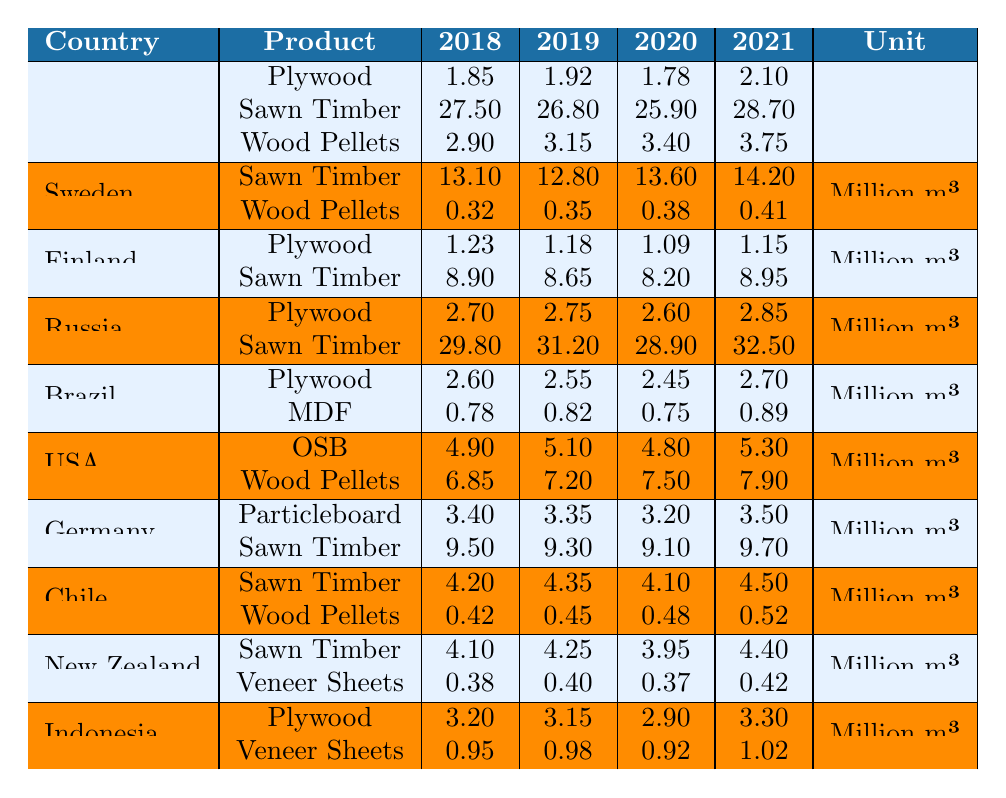What was the export volume of Sawn Timber from Canada in 2021? The table shows that exports of Sawn Timber from Canada in 2021 were 28.70 million m³.
Answer: 28.70 million m³ Which country exported the most Sawn Timber in 2020? By looking at the values for Sawn Timber in 2020, Russia exported 28.90 million m³, which is higher than any other country listed for that year.
Answer: Russia What was the total export volume of Wood Pellets from Sweden over the years 2018 to 2021? The exports of Wood Pellets from Sweden for each year are: 0.32 + 0.35 + 0.38 + 0.41 = 1.46 million m³ total.
Answer: 1.46 million m³ How much did the export volume of Plywood from Indonesia increase from 2018 to 2021? The Plywood export from Indonesia was 3.20 million m³ in 2018 and increased to 3.30 million m³ in 2021, resulting in an increase of 0.10 million m³.
Answer: 0.10 million m³ Did the export volume of Wood Pellets from the United States exceed 6 million m³ in 2019? The table indicates that the export volume for Wood Pellets from the United States in 2019 was 7.20 million m³, so it did exceed 6 million m³.
Answer: Yes What is the average export volume of Plywood for Canada over the four years? The export volumes of Plywood from Canada are: 1.85 + 1.92 + 1.78 + 2.10 = 7.65 million m³. Then, dividing that by the 4 years gives an average of 1.9125 million m³.
Answer: 1.91 million m³ Which country had the greatest fluctuation in Sawn Timber exports over the years? Examining Sawn Timber exports: Canada had fluctuation from 25.90 to 28.70 (2.80 million m³), Sweden from 12.80 to 14.20 (1.40 million m³), and Russia from 28.90 to 32.50 (3.60 million m³). Russia had the greatest fluctuation.
Answer: Russia What was the percentage growth of Wood Pellets exports from Canada from 2018 to 2021? The Wood Pellets export increased from 2.90 to 3.75 million m³. The growth is 3.75 - 2.90 = 0.85 million m³. The percentage growth is (0.85 / 2.90) * 100 = 29.31%.
Answer: 29.31% How many products are exported by Brazil? The table shows that Brazil only exports Plywood and Medium Density Fiberboard (MDF), making the total number of products 2.
Answer: 2 Which country's Wood Pellets exports decreased from 2018 to 2021? The table shows that the exports of Wood Pellets from Sweden increased in all years, while other countries like Brazil and the United States show consistent growth, indicating there is no decrease.
Answer: None What was the total volume of Sawn Timber exported by Finland from 2018 to 2021? The total Sawn Timber exported by Finland over these years is 8.90 + 8.65 + 8.20 + 8.95 = 35.70 million m³.
Answer: 35.70 million m³ 